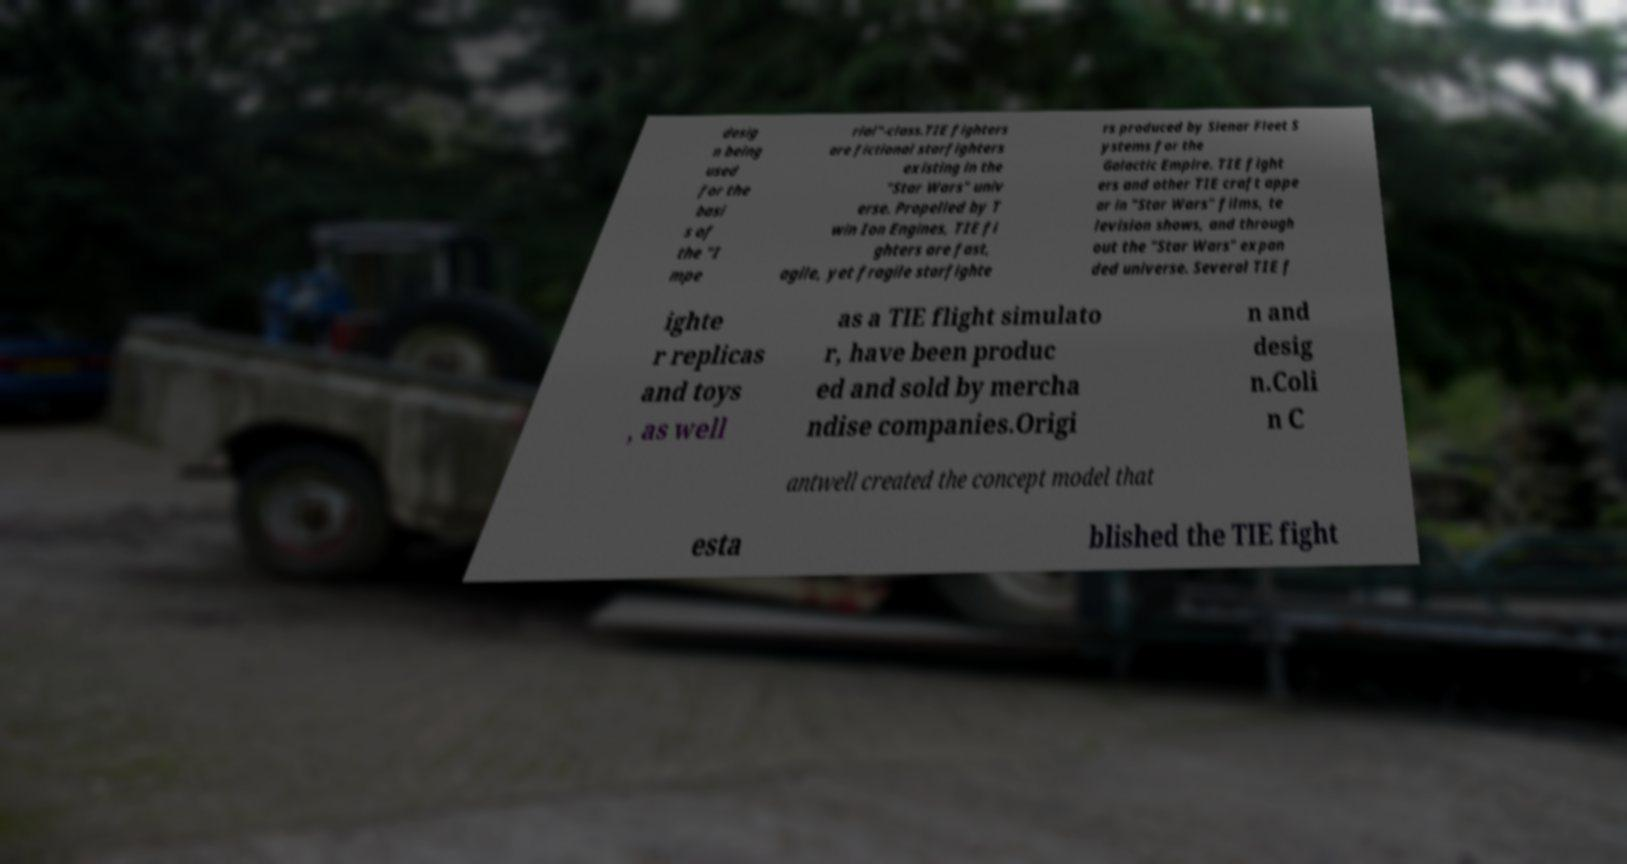Can you accurately transcribe the text from the provided image for me? desig n being used for the basi s of the "I mpe rial"-class.TIE fighters are fictional starfighters existing in the "Star Wars" univ erse. Propelled by T win Ion Engines, TIE fi ghters are fast, agile, yet fragile starfighte rs produced by Sienar Fleet S ystems for the Galactic Empire. TIE fight ers and other TIE craft appe ar in "Star Wars" films, te levision shows, and through out the "Star Wars" expan ded universe. Several TIE f ighte r replicas and toys , as well as a TIE flight simulato r, have been produc ed and sold by mercha ndise companies.Origi n and desig n.Coli n C antwell created the concept model that esta blished the TIE fight 